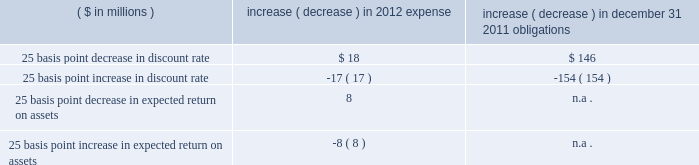Discount rate 2014the assumed discount rate is used to determine the current retirement related benefit plan expense and obligations , and represents the interest rate that is used to determine the present value of future cash flows currently expected to be required to effectively settle a plan 2019s benefit obligations .
The discount rate assumption is determined for each plan by constructing a portfolio of high quality bonds with cash flows that match the estimated outflows for future benefit payments to determine a single equivalent discount rate .
Benefit payments are not only contingent on the terms of a plan , but also on the underlying participant demographics , including current age , and assumed mortality .
We use only bonds that are denominated in u.s .
Dollars , rated aa or better by two of three nationally recognized statistical rating agencies , have a minimum outstanding issue of $ 50 million as of the measurement date , and are not callable , convertible , or index linked .
Since bond yields are generally unavailable beyond 30 years , we assume those rates will remain constant beyond that point .
Taking into consideration the factors noted above , our weighted average discount rate for pensions was 5.23% ( 5.23 % ) and 5.84% ( 5.84 % ) , as of december 31 , 2011 and 2010 , respectively .
Our weighted average discount rate for other postretirement benefits was 4.94% ( 4.94 % ) and 5.58% ( 5.58 % ) as of december 31 , 2011 and 2010 , respectively .
Expected long-term rate of return 2014the expected long-term rate of return on assets is used to calculate net periodic expense , and is based on such factors as historical returns , targeted asset allocations , investment policy , duration , expected future long-term performance of individual asset classes , inflation trends , portfolio volatility , and risk management strategies .
While studies are helpful in understanding current trends and performance , the assumption is based more on longer term and prospective views .
In order to reflect expected lower future market returns , we have reduced the expected long-term rate of return assumption from 8.50% ( 8.50 % ) , used to record 2011 expense , to 8.00% ( 8.00 % ) for 2012 .
The decrease in the expected return on assets assumption is primarily related to lower bond yields and updated return assumptions for equities .
Unless plan assets and benefit obligations are subject to remeasurement during the year , the expected return on pension assets is based on the fair value of plan assets at the beginning of the year .
An increase or decrease of 25 basis points in the discount rate and the expected long-term rate of return assumptions would have had the following approximate impacts on pensions : ( $ in millions ) increase ( decrease ) in 2012 expense increase ( decrease ) in december 31 , 2011 obligations .
Differences arising from actual experience or changes in assumptions might materially affect retirement related benefit plan obligations and the funded status .
Actuarial gains and losses arising from differences from actual experience or changes in assumptions are deferred in accumulated other comprehensive income .
This unrecognized amount is amortized to the extent it exceeds 10% ( 10 % ) of the greater of the plan 2019s benefit obligation or plan assets .
The amortization period for actuarial gains and losses is the estimated average remaining service life of the plan participants , which is approximately 10 years .
Cas expense 2014in addition to providing the methodology for calculating retirement related benefit plan costs , cas also prescribes the method for assigning those costs to specific periods .
While the ultimate liability for such costs under fas and cas is similar , the pattern of cost recognition is different .
The key drivers of cas pension expense include the funded status and the method used to calculate cas reimbursement for each of our plans as well as our expected long-term rate of return on assets assumption .
Unlike fas , cas requires the discount rate to be consistent with the expected long-term rate of return on assets assumption , which changes infrequently given its long-term nature .
As a result , changes in bond or other interest rates generally do not impact cas .
In addition , unlike under fas , we can only allocate pension costs for a plan under cas until such plan is fully funded as determined under erisa requirements .
Other fas and cas considerations 2014we update our estimates of future fas and cas costs at least annually based on factors such as calendar year actual plan asset returns , final census data from the end of the prior year , and other actual and projected experience .
A key driver of the difference between fas and cas expense ( and consequently , the fas/cas adjustment ) is the pattern of earnings and expense recognition for gains and losses that arise when our asset and liability experiences differ from our assumptions under each set of requirements .
Under fas , our net gains and losses exceeding the 10% ( 10 % ) corridor are amortized .
What is the percentage change in the weighted average discount rate for other post-retirement benefits from 2010 to 2011? 
Computations: ((4.94 - 5.58) / 5.58)
Answer: -0.1147. 